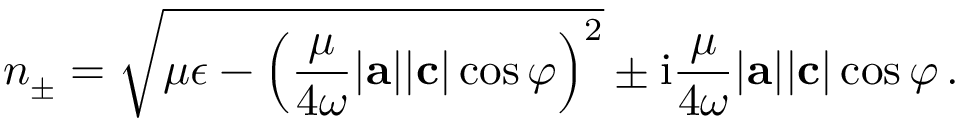<formula> <loc_0><loc_0><loc_500><loc_500>n _ { \pm } = \sqrt { \mu \epsilon - \left ( \frac { \mu } { 4 \omega } | a | | c | \cos \varphi \right ) ^ { 2 } } \pm i \frac { \mu } { 4 \omega } | a | | c | \cos \varphi \, .</formula> 